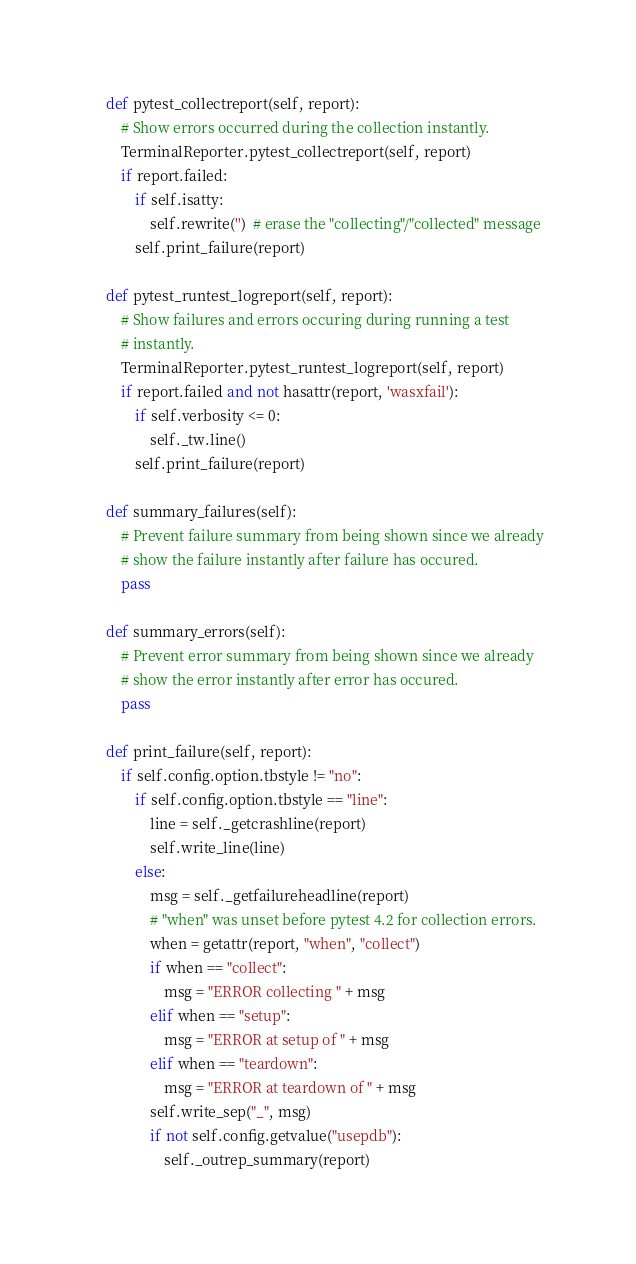<code> <loc_0><loc_0><loc_500><loc_500><_Python_>
    def pytest_collectreport(self, report):
        # Show errors occurred during the collection instantly.
        TerminalReporter.pytest_collectreport(self, report)
        if report.failed:
            if self.isatty:
                self.rewrite('')  # erase the "collecting"/"collected" message
            self.print_failure(report)

    def pytest_runtest_logreport(self, report):
        # Show failures and errors occuring during running a test
        # instantly.
        TerminalReporter.pytest_runtest_logreport(self, report)
        if report.failed and not hasattr(report, 'wasxfail'):
            if self.verbosity <= 0:
                self._tw.line()
            self.print_failure(report)

    def summary_failures(self):
        # Prevent failure summary from being shown since we already
        # show the failure instantly after failure has occured.
        pass

    def summary_errors(self):
        # Prevent error summary from being shown since we already
        # show the error instantly after error has occured.
        pass

    def print_failure(self, report):
        if self.config.option.tbstyle != "no":
            if self.config.option.tbstyle == "line":
                line = self._getcrashline(report)
                self.write_line(line)
            else:
                msg = self._getfailureheadline(report)
                # "when" was unset before pytest 4.2 for collection errors.
                when = getattr(report, "when", "collect")
                if when == "collect":
                    msg = "ERROR collecting " + msg
                elif when == "setup":
                    msg = "ERROR at setup of " + msg
                elif when == "teardown":
                    msg = "ERROR at teardown of " + msg
                self.write_sep("_", msg)
                if not self.config.getvalue("usepdb"):
                    self._outrep_summary(report)
</code> 